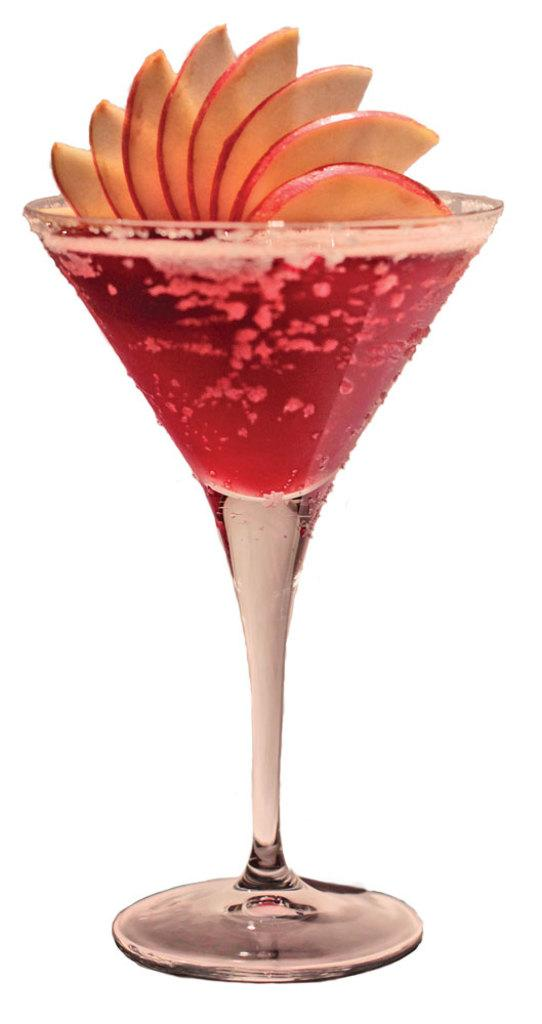What is in the glass that is visible in the image? There is a glass of juice in the image. What type of fruit is present in the image? There are apple slices in the image. What can be seen in the background of the image? There is a white surface in the background of the image. How many kittens are playing with the apple slices in the image? There are no kittens present in the image; it only features a glass of juice and apple slices. 